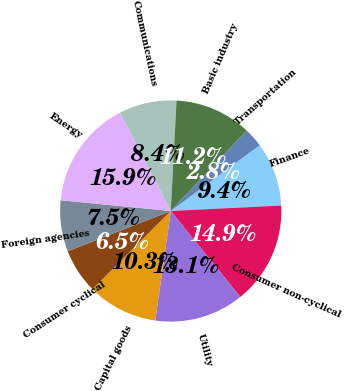<chart> <loc_0><loc_0><loc_500><loc_500><pie_chart><fcel>Finance<fcel>Consumer non-cyclical<fcel>Utility<fcel>Capital goods<fcel>Consumer cyclical<fcel>Foreign agencies<fcel>Energy<fcel>Communications<fcel>Basic industry<fcel>Transportation<nl><fcel>9.35%<fcel>14.94%<fcel>13.08%<fcel>10.28%<fcel>6.55%<fcel>7.48%<fcel>15.87%<fcel>8.42%<fcel>11.21%<fcel>2.82%<nl></chart> 